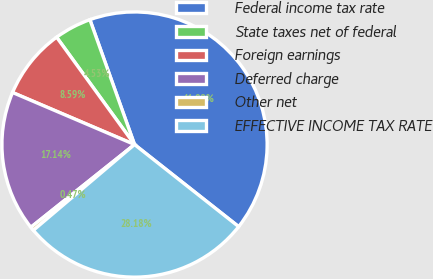<chart> <loc_0><loc_0><loc_500><loc_500><pie_chart><fcel>Federal income tax rate<fcel>State taxes net of federal<fcel>Foreign earnings<fcel>Deferred charge<fcel>Other net<fcel>EFFECTIVE INCOME TAX RATE<nl><fcel>41.09%<fcel>4.53%<fcel>8.59%<fcel>17.14%<fcel>0.47%<fcel>28.18%<nl></chart> 